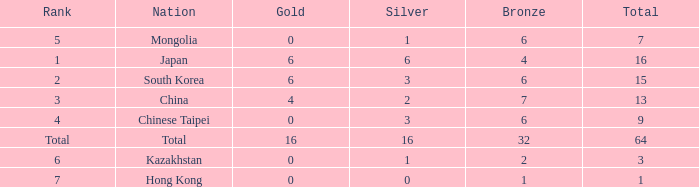Which Silver has a Nation of china, and a Bronze smaller than 7? None. 